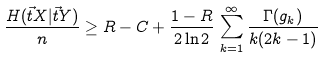Convert formula to latex. <formula><loc_0><loc_0><loc_500><loc_500>\frac { H ( \vec { t } { X } | \vec { t } { Y } ) } { n } \geq R - C + \frac { 1 - R } { 2 \ln 2 } \, \sum _ { k = 1 } ^ { \infty } \frac { \Gamma ( g _ { k } ) } { k ( 2 k - 1 ) }</formula> 